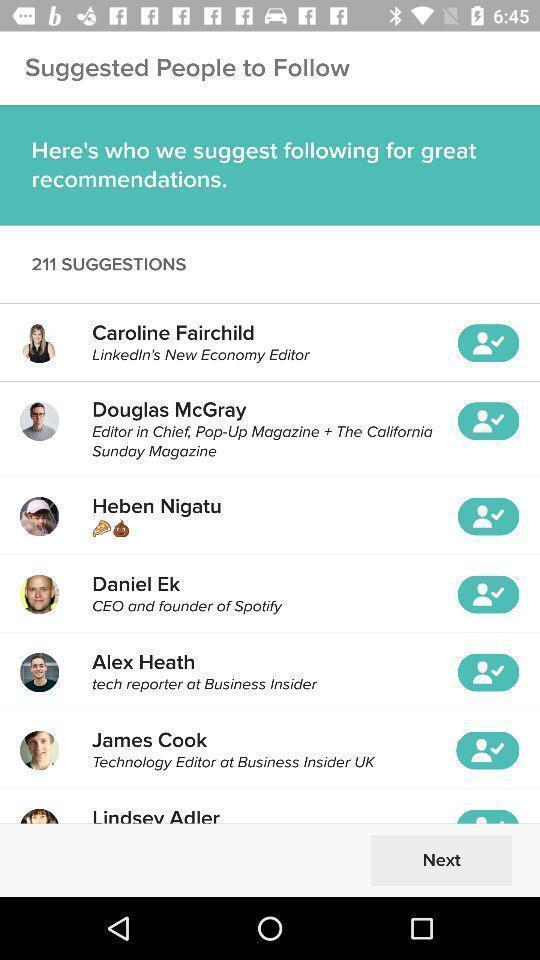What details can you identify in this image? Screen displaying the list of suggestions. 